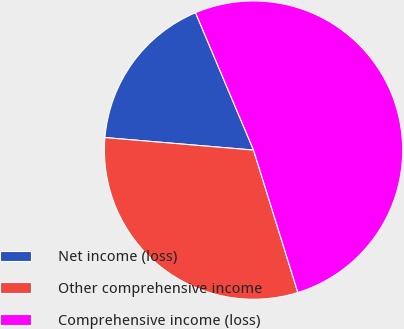<chart> <loc_0><loc_0><loc_500><loc_500><pie_chart><fcel>Net income (loss)<fcel>Other comprehensive income<fcel>Comprehensive income (loss)<nl><fcel>17.3%<fcel>31.14%<fcel>51.56%<nl></chart> 